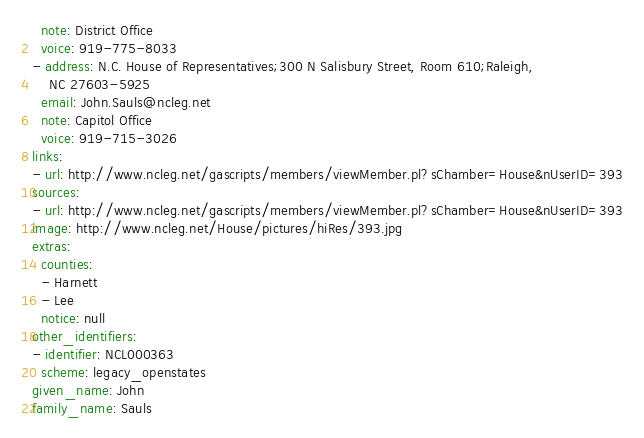<code> <loc_0><loc_0><loc_500><loc_500><_YAML_>  note: District Office
  voice: 919-775-8033
- address: N.C. House of Representatives;300 N Salisbury Street, Room 610;Raleigh,
    NC 27603-5925
  email: John.Sauls@ncleg.net
  note: Capitol Office
  voice: 919-715-3026
links:
- url: http://www.ncleg.net/gascripts/members/viewMember.pl?sChamber=House&nUserID=393
sources:
- url: http://www.ncleg.net/gascripts/members/viewMember.pl?sChamber=House&nUserID=393
image: http://www.ncleg.net/House/pictures/hiRes/393.jpg
extras:
  counties:
  - Harnett
  - Lee
  notice: null
other_identifiers:
- identifier: NCL000363
  scheme: legacy_openstates
given_name: John
family_name: Sauls
</code> 